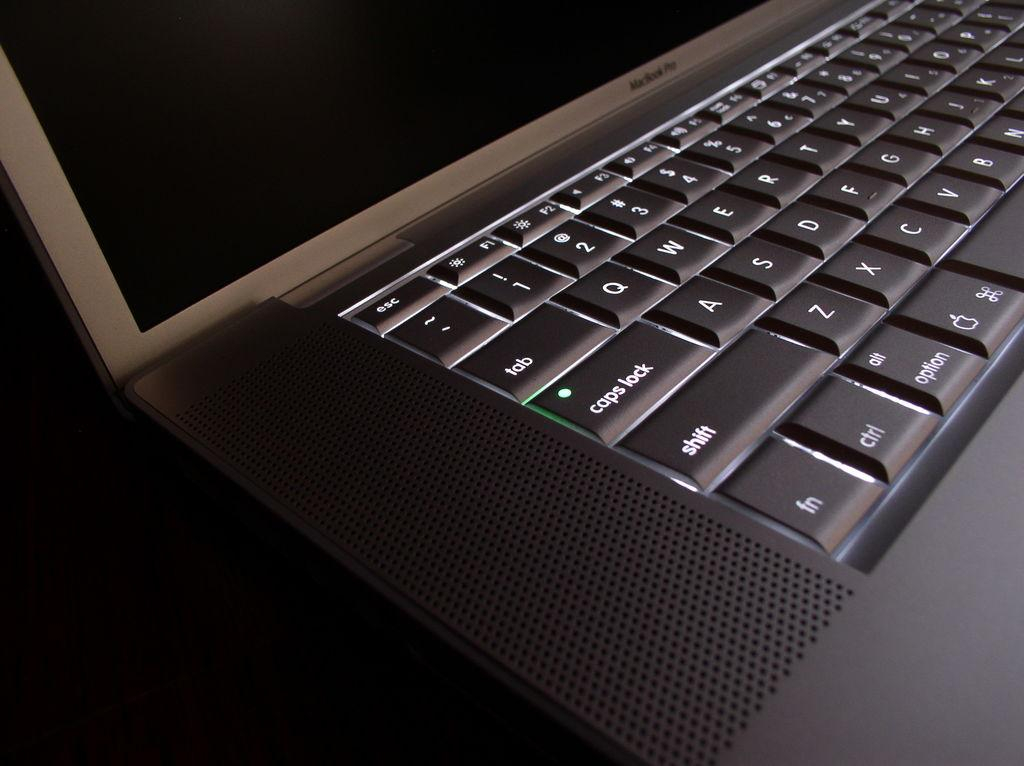Provide a one-sentence caption for the provided image. the left side of a lap top keyboard, it shows caps lock and shift amoung other things. 